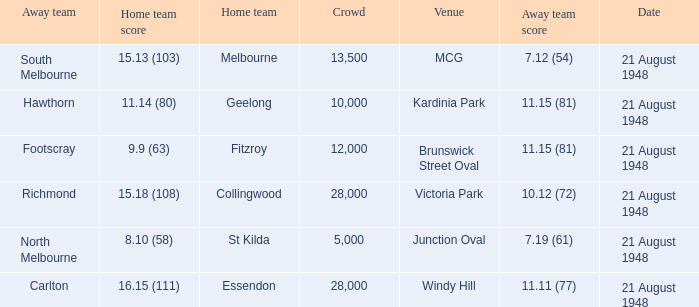If the Away team is north melbourne, what's the Home team score? 8.10 (58). 